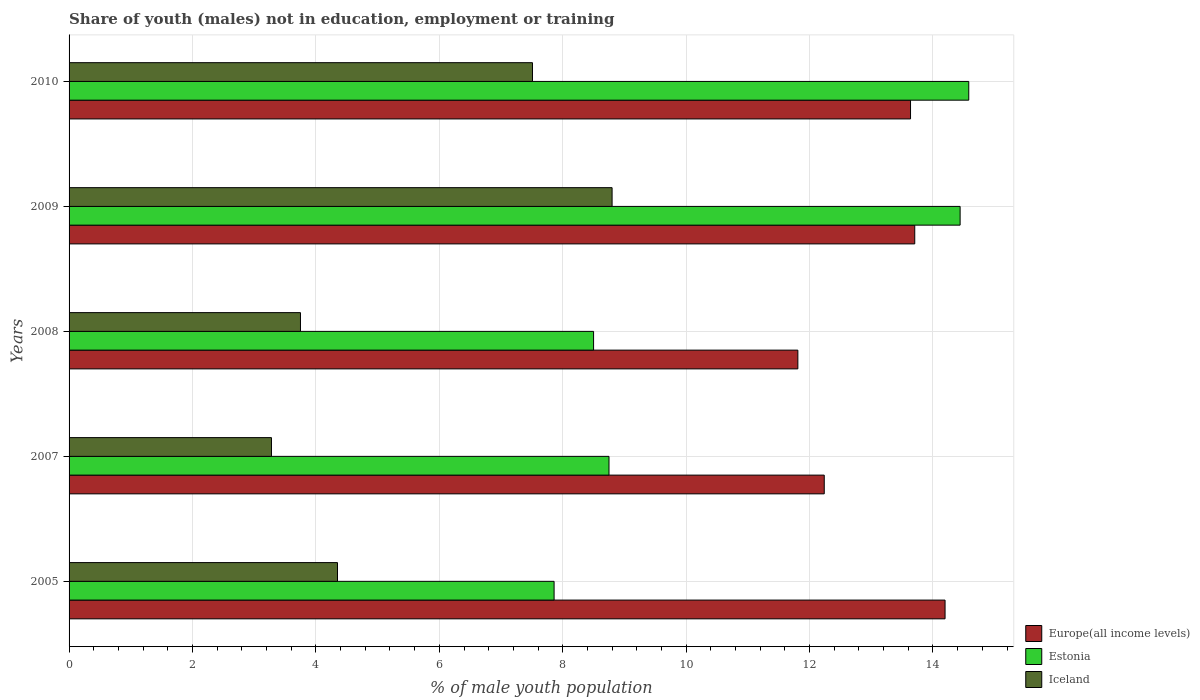How many different coloured bars are there?
Make the answer very short. 3. In how many cases, is the number of bars for a given year not equal to the number of legend labels?
Provide a succinct answer. 0. What is the percentage of unemployed males population in in Iceland in 2010?
Ensure brevity in your answer.  7.51. Across all years, what is the maximum percentage of unemployed males population in in Iceland?
Ensure brevity in your answer.  8.8. Across all years, what is the minimum percentage of unemployed males population in in Iceland?
Offer a terse response. 3.28. In which year was the percentage of unemployed males population in in Europe(all income levels) maximum?
Keep it short and to the point. 2005. What is the total percentage of unemployed males population in in Europe(all income levels) in the graph?
Offer a terse response. 65.59. What is the difference between the percentage of unemployed males population in in Iceland in 2007 and that in 2009?
Provide a succinct answer. -5.52. What is the difference between the percentage of unemployed males population in in Europe(all income levels) in 2005 and the percentage of unemployed males population in in Estonia in 2007?
Make the answer very short. 5.45. What is the average percentage of unemployed males population in in Estonia per year?
Give a very brief answer. 10.83. In the year 2009, what is the difference between the percentage of unemployed males population in in Iceland and percentage of unemployed males population in in Europe(all income levels)?
Your response must be concise. -4.9. What is the ratio of the percentage of unemployed males population in in Iceland in 2005 to that in 2010?
Offer a terse response. 0.58. Is the percentage of unemployed males population in in Iceland in 2005 less than that in 2009?
Keep it short and to the point. Yes. What is the difference between the highest and the second highest percentage of unemployed males population in in Estonia?
Ensure brevity in your answer.  0.14. What is the difference between the highest and the lowest percentage of unemployed males population in in Estonia?
Make the answer very short. 6.72. What does the 1st bar from the top in 2010 represents?
Provide a short and direct response. Iceland. What does the 2nd bar from the bottom in 2009 represents?
Keep it short and to the point. Estonia. Is it the case that in every year, the sum of the percentage of unemployed males population in in Iceland and percentage of unemployed males population in in Estonia is greater than the percentage of unemployed males population in in Europe(all income levels)?
Provide a succinct answer. No. How many bars are there?
Your answer should be very brief. 15. Are all the bars in the graph horizontal?
Keep it short and to the point. Yes. How many years are there in the graph?
Ensure brevity in your answer.  5. Where does the legend appear in the graph?
Provide a succinct answer. Bottom right. How are the legend labels stacked?
Offer a very short reply. Vertical. What is the title of the graph?
Give a very brief answer. Share of youth (males) not in education, employment or training. What is the label or title of the X-axis?
Your response must be concise. % of male youth population. What is the % of male youth population in Europe(all income levels) in 2005?
Your answer should be very brief. 14.2. What is the % of male youth population in Estonia in 2005?
Make the answer very short. 7.86. What is the % of male youth population of Iceland in 2005?
Offer a very short reply. 4.35. What is the % of male youth population in Europe(all income levels) in 2007?
Make the answer very short. 12.24. What is the % of male youth population of Estonia in 2007?
Offer a very short reply. 8.75. What is the % of male youth population of Iceland in 2007?
Ensure brevity in your answer.  3.28. What is the % of male youth population of Europe(all income levels) in 2008?
Offer a very short reply. 11.81. What is the % of male youth population of Iceland in 2008?
Ensure brevity in your answer.  3.75. What is the % of male youth population in Europe(all income levels) in 2009?
Ensure brevity in your answer.  13.7. What is the % of male youth population of Estonia in 2009?
Your answer should be compact. 14.44. What is the % of male youth population of Iceland in 2009?
Your answer should be very brief. 8.8. What is the % of male youth population of Europe(all income levels) in 2010?
Provide a short and direct response. 13.64. What is the % of male youth population in Estonia in 2010?
Your response must be concise. 14.58. What is the % of male youth population of Iceland in 2010?
Ensure brevity in your answer.  7.51. Across all years, what is the maximum % of male youth population of Europe(all income levels)?
Your answer should be very brief. 14.2. Across all years, what is the maximum % of male youth population of Estonia?
Ensure brevity in your answer.  14.58. Across all years, what is the maximum % of male youth population of Iceland?
Keep it short and to the point. 8.8. Across all years, what is the minimum % of male youth population in Europe(all income levels)?
Give a very brief answer. 11.81. Across all years, what is the minimum % of male youth population of Estonia?
Provide a succinct answer. 7.86. Across all years, what is the minimum % of male youth population in Iceland?
Ensure brevity in your answer.  3.28. What is the total % of male youth population in Europe(all income levels) in the graph?
Offer a terse response. 65.59. What is the total % of male youth population in Estonia in the graph?
Your answer should be very brief. 54.13. What is the total % of male youth population of Iceland in the graph?
Offer a terse response. 27.69. What is the difference between the % of male youth population of Europe(all income levels) in 2005 and that in 2007?
Provide a short and direct response. 1.96. What is the difference between the % of male youth population of Estonia in 2005 and that in 2007?
Ensure brevity in your answer.  -0.89. What is the difference between the % of male youth population in Iceland in 2005 and that in 2007?
Provide a short and direct response. 1.07. What is the difference between the % of male youth population of Europe(all income levels) in 2005 and that in 2008?
Offer a very short reply. 2.39. What is the difference between the % of male youth population of Estonia in 2005 and that in 2008?
Give a very brief answer. -0.64. What is the difference between the % of male youth population of Europe(all income levels) in 2005 and that in 2009?
Give a very brief answer. 0.49. What is the difference between the % of male youth population of Estonia in 2005 and that in 2009?
Your answer should be very brief. -6.58. What is the difference between the % of male youth population in Iceland in 2005 and that in 2009?
Give a very brief answer. -4.45. What is the difference between the % of male youth population in Europe(all income levels) in 2005 and that in 2010?
Your answer should be very brief. 0.56. What is the difference between the % of male youth population in Estonia in 2005 and that in 2010?
Your answer should be compact. -6.72. What is the difference between the % of male youth population in Iceland in 2005 and that in 2010?
Your answer should be very brief. -3.16. What is the difference between the % of male youth population of Europe(all income levels) in 2007 and that in 2008?
Keep it short and to the point. 0.43. What is the difference between the % of male youth population in Iceland in 2007 and that in 2008?
Offer a terse response. -0.47. What is the difference between the % of male youth population in Europe(all income levels) in 2007 and that in 2009?
Offer a terse response. -1.47. What is the difference between the % of male youth population in Estonia in 2007 and that in 2009?
Provide a succinct answer. -5.69. What is the difference between the % of male youth population of Iceland in 2007 and that in 2009?
Provide a succinct answer. -5.52. What is the difference between the % of male youth population in Europe(all income levels) in 2007 and that in 2010?
Give a very brief answer. -1.4. What is the difference between the % of male youth population of Estonia in 2007 and that in 2010?
Give a very brief answer. -5.83. What is the difference between the % of male youth population of Iceland in 2007 and that in 2010?
Provide a succinct answer. -4.23. What is the difference between the % of male youth population in Europe(all income levels) in 2008 and that in 2009?
Offer a terse response. -1.89. What is the difference between the % of male youth population of Estonia in 2008 and that in 2009?
Make the answer very short. -5.94. What is the difference between the % of male youth population of Iceland in 2008 and that in 2009?
Provide a short and direct response. -5.05. What is the difference between the % of male youth population of Europe(all income levels) in 2008 and that in 2010?
Make the answer very short. -1.83. What is the difference between the % of male youth population in Estonia in 2008 and that in 2010?
Ensure brevity in your answer.  -6.08. What is the difference between the % of male youth population of Iceland in 2008 and that in 2010?
Ensure brevity in your answer.  -3.76. What is the difference between the % of male youth population of Europe(all income levels) in 2009 and that in 2010?
Provide a short and direct response. 0.07. What is the difference between the % of male youth population of Estonia in 2009 and that in 2010?
Your answer should be very brief. -0.14. What is the difference between the % of male youth population of Iceland in 2009 and that in 2010?
Ensure brevity in your answer.  1.29. What is the difference between the % of male youth population in Europe(all income levels) in 2005 and the % of male youth population in Estonia in 2007?
Make the answer very short. 5.45. What is the difference between the % of male youth population in Europe(all income levels) in 2005 and the % of male youth population in Iceland in 2007?
Keep it short and to the point. 10.92. What is the difference between the % of male youth population of Estonia in 2005 and the % of male youth population of Iceland in 2007?
Offer a very short reply. 4.58. What is the difference between the % of male youth population of Europe(all income levels) in 2005 and the % of male youth population of Estonia in 2008?
Ensure brevity in your answer.  5.7. What is the difference between the % of male youth population in Europe(all income levels) in 2005 and the % of male youth population in Iceland in 2008?
Keep it short and to the point. 10.45. What is the difference between the % of male youth population in Estonia in 2005 and the % of male youth population in Iceland in 2008?
Provide a short and direct response. 4.11. What is the difference between the % of male youth population in Europe(all income levels) in 2005 and the % of male youth population in Estonia in 2009?
Offer a very short reply. -0.24. What is the difference between the % of male youth population in Europe(all income levels) in 2005 and the % of male youth population in Iceland in 2009?
Keep it short and to the point. 5.4. What is the difference between the % of male youth population in Estonia in 2005 and the % of male youth population in Iceland in 2009?
Ensure brevity in your answer.  -0.94. What is the difference between the % of male youth population in Europe(all income levels) in 2005 and the % of male youth population in Estonia in 2010?
Offer a very short reply. -0.38. What is the difference between the % of male youth population of Europe(all income levels) in 2005 and the % of male youth population of Iceland in 2010?
Keep it short and to the point. 6.69. What is the difference between the % of male youth population of Estonia in 2005 and the % of male youth population of Iceland in 2010?
Ensure brevity in your answer.  0.35. What is the difference between the % of male youth population in Europe(all income levels) in 2007 and the % of male youth population in Estonia in 2008?
Offer a very short reply. 3.74. What is the difference between the % of male youth population in Europe(all income levels) in 2007 and the % of male youth population in Iceland in 2008?
Provide a short and direct response. 8.49. What is the difference between the % of male youth population in Europe(all income levels) in 2007 and the % of male youth population in Estonia in 2009?
Give a very brief answer. -2.2. What is the difference between the % of male youth population of Europe(all income levels) in 2007 and the % of male youth population of Iceland in 2009?
Offer a terse response. 3.44. What is the difference between the % of male youth population in Europe(all income levels) in 2007 and the % of male youth population in Estonia in 2010?
Offer a very short reply. -2.34. What is the difference between the % of male youth population in Europe(all income levels) in 2007 and the % of male youth population in Iceland in 2010?
Make the answer very short. 4.73. What is the difference between the % of male youth population of Estonia in 2007 and the % of male youth population of Iceland in 2010?
Provide a short and direct response. 1.24. What is the difference between the % of male youth population of Europe(all income levels) in 2008 and the % of male youth population of Estonia in 2009?
Offer a terse response. -2.63. What is the difference between the % of male youth population in Europe(all income levels) in 2008 and the % of male youth population in Iceland in 2009?
Your response must be concise. 3.01. What is the difference between the % of male youth population of Europe(all income levels) in 2008 and the % of male youth population of Estonia in 2010?
Ensure brevity in your answer.  -2.77. What is the difference between the % of male youth population of Europe(all income levels) in 2008 and the % of male youth population of Iceland in 2010?
Your answer should be compact. 4.3. What is the difference between the % of male youth population of Estonia in 2008 and the % of male youth population of Iceland in 2010?
Ensure brevity in your answer.  0.99. What is the difference between the % of male youth population of Europe(all income levels) in 2009 and the % of male youth population of Estonia in 2010?
Ensure brevity in your answer.  -0.88. What is the difference between the % of male youth population in Europe(all income levels) in 2009 and the % of male youth population in Iceland in 2010?
Your answer should be very brief. 6.19. What is the difference between the % of male youth population in Estonia in 2009 and the % of male youth population in Iceland in 2010?
Your answer should be compact. 6.93. What is the average % of male youth population in Europe(all income levels) per year?
Your answer should be compact. 13.12. What is the average % of male youth population of Estonia per year?
Your answer should be very brief. 10.83. What is the average % of male youth population of Iceland per year?
Keep it short and to the point. 5.54. In the year 2005, what is the difference between the % of male youth population in Europe(all income levels) and % of male youth population in Estonia?
Provide a succinct answer. 6.34. In the year 2005, what is the difference between the % of male youth population in Europe(all income levels) and % of male youth population in Iceland?
Keep it short and to the point. 9.85. In the year 2005, what is the difference between the % of male youth population in Estonia and % of male youth population in Iceland?
Provide a short and direct response. 3.51. In the year 2007, what is the difference between the % of male youth population of Europe(all income levels) and % of male youth population of Estonia?
Provide a succinct answer. 3.49. In the year 2007, what is the difference between the % of male youth population of Europe(all income levels) and % of male youth population of Iceland?
Your answer should be compact. 8.96. In the year 2007, what is the difference between the % of male youth population in Estonia and % of male youth population in Iceland?
Offer a very short reply. 5.47. In the year 2008, what is the difference between the % of male youth population in Europe(all income levels) and % of male youth population in Estonia?
Give a very brief answer. 3.31. In the year 2008, what is the difference between the % of male youth population of Europe(all income levels) and % of male youth population of Iceland?
Offer a terse response. 8.06. In the year 2008, what is the difference between the % of male youth population of Estonia and % of male youth population of Iceland?
Provide a short and direct response. 4.75. In the year 2009, what is the difference between the % of male youth population in Europe(all income levels) and % of male youth population in Estonia?
Your answer should be very brief. -0.74. In the year 2009, what is the difference between the % of male youth population of Europe(all income levels) and % of male youth population of Iceland?
Provide a short and direct response. 4.9. In the year 2009, what is the difference between the % of male youth population in Estonia and % of male youth population in Iceland?
Provide a succinct answer. 5.64. In the year 2010, what is the difference between the % of male youth population of Europe(all income levels) and % of male youth population of Estonia?
Offer a terse response. -0.94. In the year 2010, what is the difference between the % of male youth population in Europe(all income levels) and % of male youth population in Iceland?
Your answer should be compact. 6.13. In the year 2010, what is the difference between the % of male youth population of Estonia and % of male youth population of Iceland?
Provide a succinct answer. 7.07. What is the ratio of the % of male youth population in Europe(all income levels) in 2005 to that in 2007?
Ensure brevity in your answer.  1.16. What is the ratio of the % of male youth population of Estonia in 2005 to that in 2007?
Make the answer very short. 0.9. What is the ratio of the % of male youth population of Iceland in 2005 to that in 2007?
Give a very brief answer. 1.33. What is the ratio of the % of male youth population of Europe(all income levels) in 2005 to that in 2008?
Offer a very short reply. 1.2. What is the ratio of the % of male youth population of Estonia in 2005 to that in 2008?
Provide a short and direct response. 0.92. What is the ratio of the % of male youth population in Iceland in 2005 to that in 2008?
Provide a short and direct response. 1.16. What is the ratio of the % of male youth population in Europe(all income levels) in 2005 to that in 2009?
Keep it short and to the point. 1.04. What is the ratio of the % of male youth population of Estonia in 2005 to that in 2009?
Offer a terse response. 0.54. What is the ratio of the % of male youth population of Iceland in 2005 to that in 2009?
Make the answer very short. 0.49. What is the ratio of the % of male youth population of Europe(all income levels) in 2005 to that in 2010?
Your response must be concise. 1.04. What is the ratio of the % of male youth population of Estonia in 2005 to that in 2010?
Ensure brevity in your answer.  0.54. What is the ratio of the % of male youth population of Iceland in 2005 to that in 2010?
Your answer should be very brief. 0.58. What is the ratio of the % of male youth population in Europe(all income levels) in 2007 to that in 2008?
Your answer should be very brief. 1.04. What is the ratio of the % of male youth population of Estonia in 2007 to that in 2008?
Your answer should be very brief. 1.03. What is the ratio of the % of male youth population in Iceland in 2007 to that in 2008?
Provide a short and direct response. 0.87. What is the ratio of the % of male youth population of Europe(all income levels) in 2007 to that in 2009?
Ensure brevity in your answer.  0.89. What is the ratio of the % of male youth population in Estonia in 2007 to that in 2009?
Make the answer very short. 0.61. What is the ratio of the % of male youth population in Iceland in 2007 to that in 2009?
Provide a succinct answer. 0.37. What is the ratio of the % of male youth population of Europe(all income levels) in 2007 to that in 2010?
Ensure brevity in your answer.  0.9. What is the ratio of the % of male youth population in Estonia in 2007 to that in 2010?
Offer a very short reply. 0.6. What is the ratio of the % of male youth population in Iceland in 2007 to that in 2010?
Ensure brevity in your answer.  0.44. What is the ratio of the % of male youth population of Europe(all income levels) in 2008 to that in 2009?
Offer a terse response. 0.86. What is the ratio of the % of male youth population of Estonia in 2008 to that in 2009?
Give a very brief answer. 0.59. What is the ratio of the % of male youth population of Iceland in 2008 to that in 2009?
Your answer should be compact. 0.43. What is the ratio of the % of male youth population of Europe(all income levels) in 2008 to that in 2010?
Keep it short and to the point. 0.87. What is the ratio of the % of male youth population of Estonia in 2008 to that in 2010?
Your answer should be very brief. 0.58. What is the ratio of the % of male youth population of Iceland in 2008 to that in 2010?
Keep it short and to the point. 0.5. What is the ratio of the % of male youth population of Europe(all income levels) in 2009 to that in 2010?
Give a very brief answer. 1. What is the ratio of the % of male youth population in Iceland in 2009 to that in 2010?
Offer a terse response. 1.17. What is the difference between the highest and the second highest % of male youth population of Europe(all income levels)?
Offer a very short reply. 0.49. What is the difference between the highest and the second highest % of male youth population in Estonia?
Your response must be concise. 0.14. What is the difference between the highest and the second highest % of male youth population of Iceland?
Provide a short and direct response. 1.29. What is the difference between the highest and the lowest % of male youth population in Europe(all income levels)?
Make the answer very short. 2.39. What is the difference between the highest and the lowest % of male youth population in Estonia?
Offer a very short reply. 6.72. What is the difference between the highest and the lowest % of male youth population of Iceland?
Make the answer very short. 5.52. 